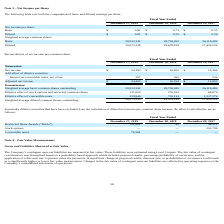From Chefs Wharehouse's financial document, What is the adjusted net income for fiscal years 2019, 2018 and 2017 respectively? The document contains multiple relevant values: $24,400, $20,764, $14,902. From the document: "Adjusted net income $ 24,400 $ 20,764 $ 14,902 Adjusted net income $ 24,400 $ 20,764 $ 14,902 Adjusted net income $ 24,400 $ 20,764 $ 14,902..." Also, What is the Weighted average basic common shares outstanding for fiscal years 2019, 2018 and 2017 respectively? The document contains multiple relevant values: 29,532,342, 28,703,265, 26,118,482. From the document: "Weighted average basic common shares outstanding 29,532,342 28,703,265 26,118,482 verage basic common shares outstanding 29,532,342 28,703,265 26,118,..." Also, What is the Weighted average diluted common shares outstanding for fiscal years 2019, 2018 and 2017 respectively? The document contains multiple relevant values: 30,073,338, 29,678,919, 27,424,526. From the document: "eighted average diluted common shares outstanding 30,073,338 29,678,919 27,424,526 rage diluted common shares outstanding 30,073,338 29,678,919 27,424..." Also, can you calculate: What is the change in the adjusted net income between 2018 and 2019? Based on the calculation: 24,400-20,764, the result is 3636. This is based on the information: "Adjusted net income $ 24,400 $ 20,764 $ 14,902 Adjusted net income $ 24,400 $ 20,764 $ 14,902..." The key data points involved are: 20,764, 24,400. Additionally, Which year has the highest adjusted net income? According to the financial document, 2019. The relevant text states: "December 27, 2019 December 28, 2018 December 29, 2017..." Also, can you calculate: What is the average adjusted net income from 2017-2019? To answer this question, I need to perform calculations using the financial data. The calculation is: (24,400+ 20,764+ 14,902)/3, which equals 20022. This is based on the information: "Adjusted net income $ 24,400 $ 20,764 $ 14,902 Adjusted net income $ 24,400 $ 20,764 $ 14,902 Adjusted net income $ 24,400 $ 20,764 $ 14,902..." The key data points involved are: 14,902, 20,764, 24,400. 